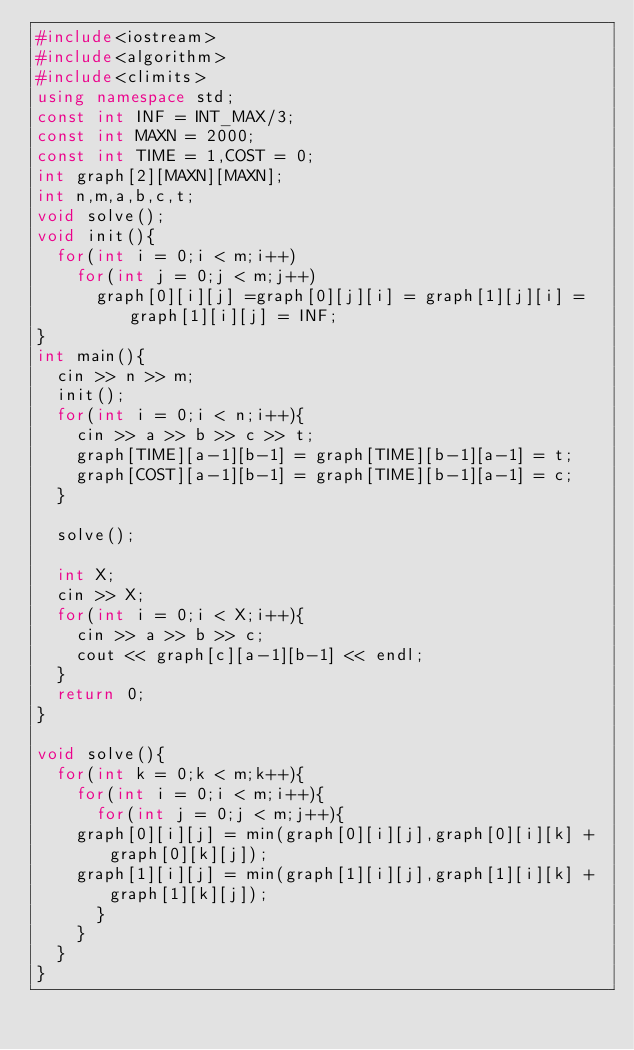Convert code to text. <code><loc_0><loc_0><loc_500><loc_500><_C++_>#include<iostream>
#include<algorithm>
#include<climits>
using namespace std;
const int INF = INT_MAX/3;
const int MAXN = 2000;
const int TIME = 1,COST = 0;
int graph[2][MAXN][MAXN];
int n,m,a,b,c,t;
void solve();
void init(){
  for(int i = 0;i < m;i++)
    for(int j = 0;j < m;j++)
      graph[0][i][j] =graph[0][j][i] = graph[1][j][i] = graph[1][i][j] = INF;
}
int main(){
  cin >> n >> m;
  init();
  for(int i = 0;i < n;i++){
    cin >> a >> b >> c >> t;
    graph[TIME][a-1][b-1] = graph[TIME][b-1][a-1] = t;
    graph[COST][a-1][b-1] = graph[TIME][b-1][a-1] = c;
  }

  solve();
  
  int X;
  cin >> X;
  for(int i = 0;i < X;i++){
    cin >> a >> b >> c;
    cout << graph[c][a-1][b-1] << endl;
  }
  return 0;
}

void solve(){
  for(int k = 0;k < m;k++){
    for(int i = 0;i < m;i++){
      for(int j = 0;j < m;j++){
	graph[0][i][j] = min(graph[0][i][j],graph[0][i][k] + graph[0][k][j]);
	graph[1][i][j] = min(graph[1][i][j],graph[1][i][k] + graph[1][k][j]);
      }
    }
  }
}</code> 